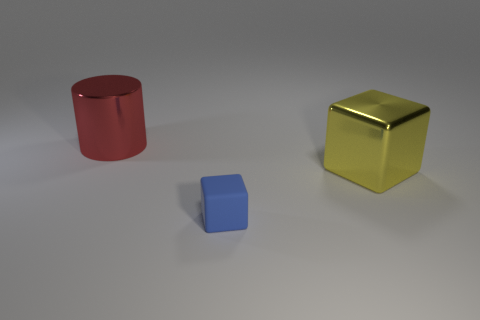Can you infer anything about the light source in this scene? The light source in the scene appears to be coming from above and to the right, given the placement of shadows and highlights on the objects. The shadows are soft, suggesting the light source is diffused, which could be indicative of an overcast sky or a large diffuser used in indoor lighting. How do the shadows contribute to the depth of the scene? The shadows create a sense of three-dimensionality and help to define the spatial relationships between the objects. They contribute to the viewer's ability to perceive the relative sizes and distances of the objects in the scene, enhancing the overall sense of depth. 